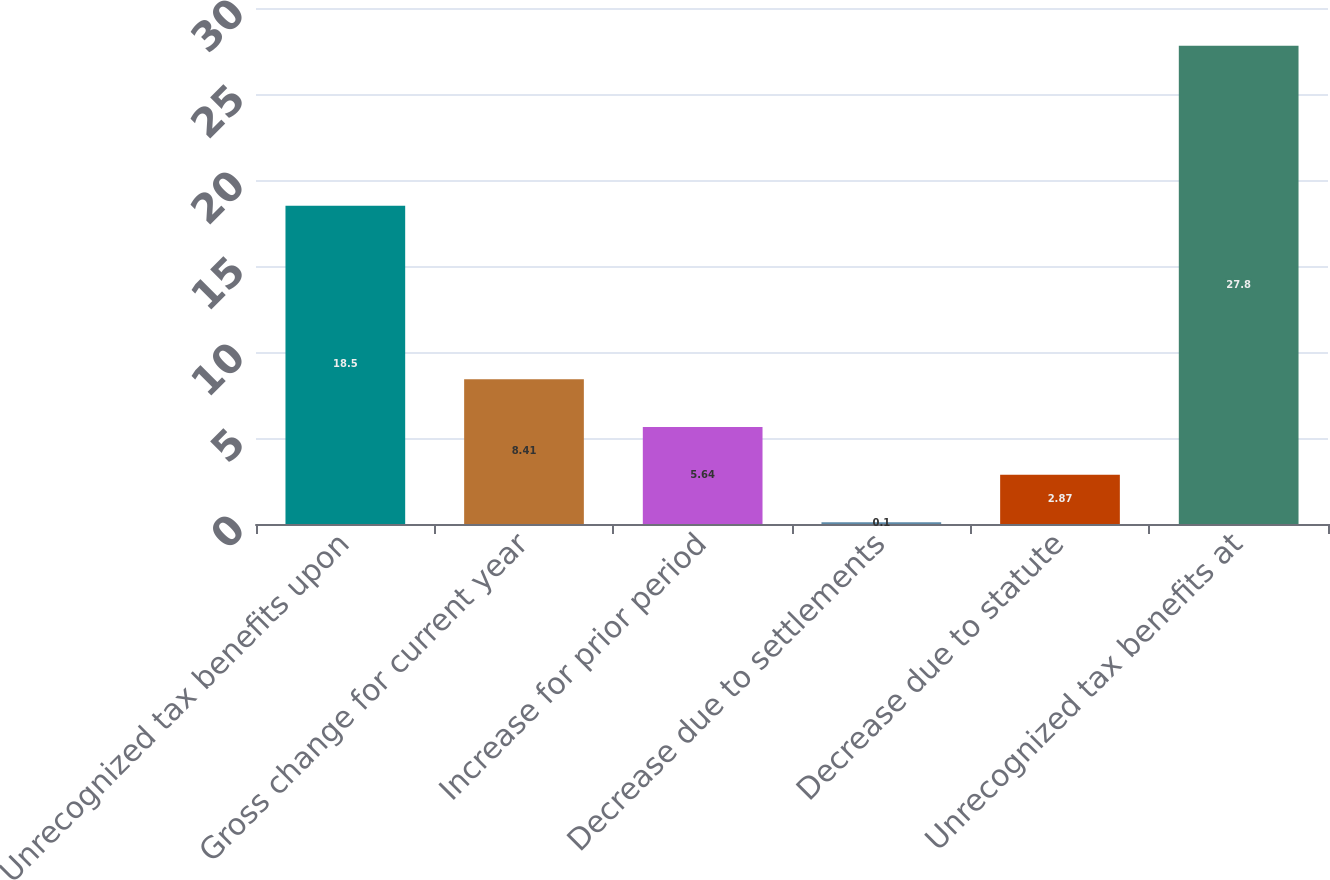Convert chart to OTSL. <chart><loc_0><loc_0><loc_500><loc_500><bar_chart><fcel>Unrecognized tax benefits upon<fcel>Gross change for current year<fcel>Increase for prior period<fcel>Decrease due to settlements<fcel>Decrease due to statute<fcel>Unrecognized tax benefits at<nl><fcel>18.5<fcel>8.41<fcel>5.64<fcel>0.1<fcel>2.87<fcel>27.8<nl></chart> 